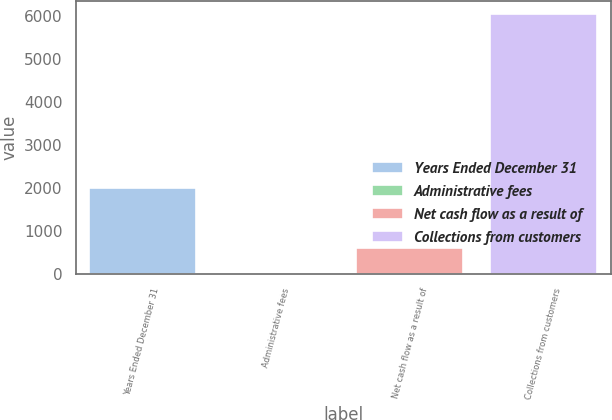Convert chart. <chart><loc_0><loc_0><loc_500><loc_500><bar_chart><fcel>Years Ended December 31<fcel>Administrative fees<fcel>Net cash flow as a result of<fcel>Collections from customers<nl><fcel>2008<fcel>1<fcel>606.9<fcel>6060<nl></chart> 